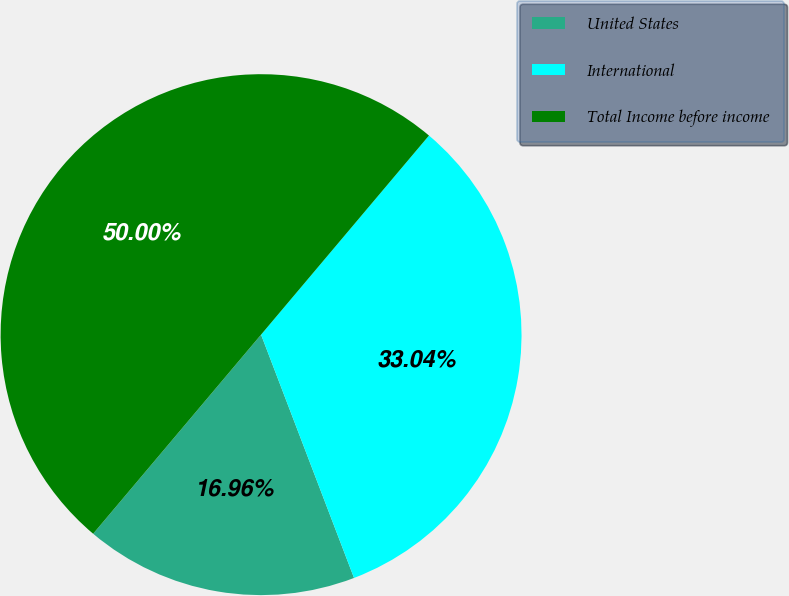Convert chart to OTSL. <chart><loc_0><loc_0><loc_500><loc_500><pie_chart><fcel>United States<fcel>International<fcel>Total Income before income<nl><fcel>16.96%<fcel>33.04%<fcel>50.0%<nl></chart> 